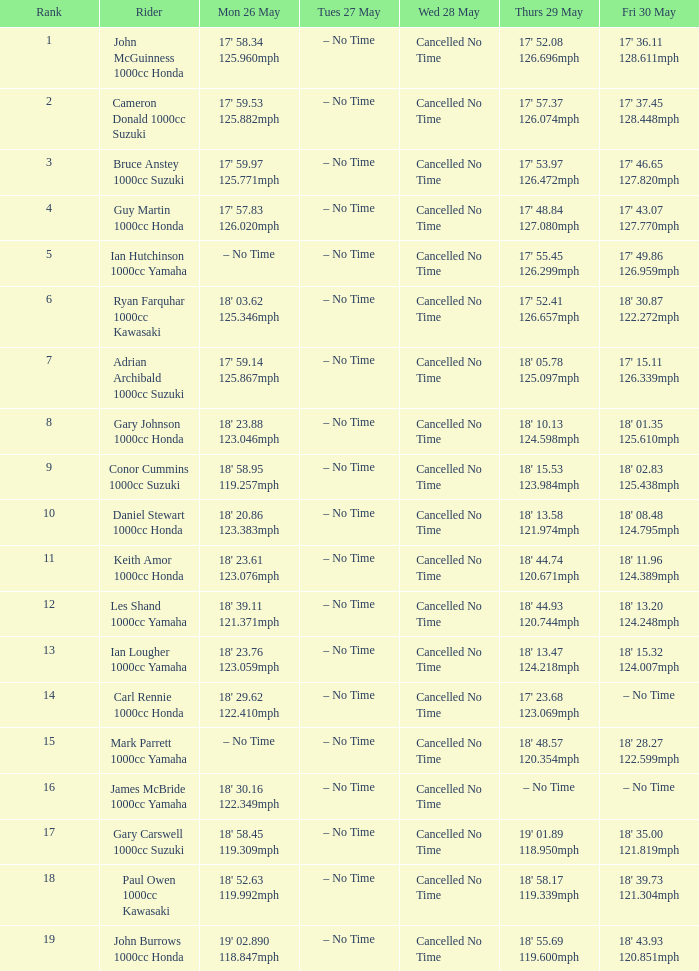I'm looking to parse the entire table for insights. Could you assist me with that? {'header': ['Rank', 'Rider', 'Mon 26 May', 'Tues 27 May', 'Wed 28 May', 'Thurs 29 May', 'Fri 30 May'], 'rows': [['1', 'John McGuinness 1000cc Honda', "17' 58.34 125.960mph", '– No Time', 'Cancelled No Time', "17' 52.08 126.696mph", "17' 36.11 128.611mph"], ['2', 'Cameron Donald 1000cc Suzuki', "17' 59.53 125.882mph", '– No Time', 'Cancelled No Time', "17' 57.37 126.074mph", "17' 37.45 128.448mph"], ['3', 'Bruce Anstey 1000cc Suzuki', "17' 59.97 125.771mph", '– No Time', 'Cancelled No Time', "17' 53.97 126.472mph", "17' 46.65 127.820mph"], ['4', 'Guy Martin 1000cc Honda', "17' 57.83 126.020mph", '– No Time', 'Cancelled No Time', "17' 48.84 127.080mph", "17' 43.07 127.770mph"], ['5', 'Ian Hutchinson 1000cc Yamaha', '– No Time', '– No Time', 'Cancelled No Time', "17' 55.45 126.299mph", "17' 49.86 126.959mph"], ['6', 'Ryan Farquhar 1000cc Kawasaki', "18' 03.62 125.346mph", '– No Time', 'Cancelled No Time', "17' 52.41 126.657mph", "18' 30.87 122.272mph"], ['7', 'Adrian Archibald 1000cc Suzuki', "17' 59.14 125.867mph", '– No Time', 'Cancelled No Time', "18' 05.78 125.097mph", "17' 15.11 126.339mph"], ['8', 'Gary Johnson 1000cc Honda', "18' 23.88 123.046mph", '– No Time', 'Cancelled No Time', "18' 10.13 124.598mph", "18' 01.35 125.610mph"], ['9', 'Conor Cummins 1000cc Suzuki', "18' 58.95 119.257mph", '– No Time', 'Cancelled No Time', "18' 15.53 123.984mph", "18' 02.83 125.438mph"], ['10', 'Daniel Stewart 1000cc Honda', "18' 20.86 123.383mph", '– No Time', 'Cancelled No Time', "18' 13.58 121.974mph", "18' 08.48 124.795mph"], ['11', 'Keith Amor 1000cc Honda', "18' 23.61 123.076mph", '– No Time', 'Cancelled No Time', "18' 44.74 120.671mph", "18' 11.96 124.389mph"], ['12', 'Les Shand 1000cc Yamaha', "18' 39.11 121.371mph", '– No Time', 'Cancelled No Time', "18' 44.93 120.744mph", "18' 13.20 124.248mph"], ['13', 'Ian Lougher 1000cc Yamaha', "18' 23.76 123.059mph", '– No Time', 'Cancelled No Time', "18' 13.47 124.218mph", "18' 15.32 124.007mph"], ['14', 'Carl Rennie 1000cc Honda', "18' 29.62 122.410mph", '– No Time', 'Cancelled No Time', "17' 23.68 123.069mph", '– No Time'], ['15', 'Mark Parrett 1000cc Yamaha', '– No Time', '– No Time', 'Cancelled No Time', "18' 48.57 120.354mph", "18' 28.27 122.599mph"], ['16', 'James McBride 1000cc Yamaha', "18' 30.16 122.349mph", '– No Time', 'Cancelled No Time', '– No Time', '– No Time'], ['17', 'Gary Carswell 1000cc Suzuki', "18' 58.45 119.309mph", '– No Time', 'Cancelled No Time', "19' 01.89 118.950mph", "18' 35.00 121.819mph"], ['18', 'Paul Owen 1000cc Kawasaki', "18' 52.63 119.992mph", '– No Time', 'Cancelled No Time', "18' 58.17 119.339mph", "18' 39.73 121.304mph"], ['19', 'John Burrows 1000cc Honda', "19' 02.890 118.847mph", '– No Time', 'Cancelled No Time', "18' 55.69 119.600mph", "18' 43.93 120.851mph"]]} What hour is mon may 26 and fri may 30 at 18' 2 – No Time. 